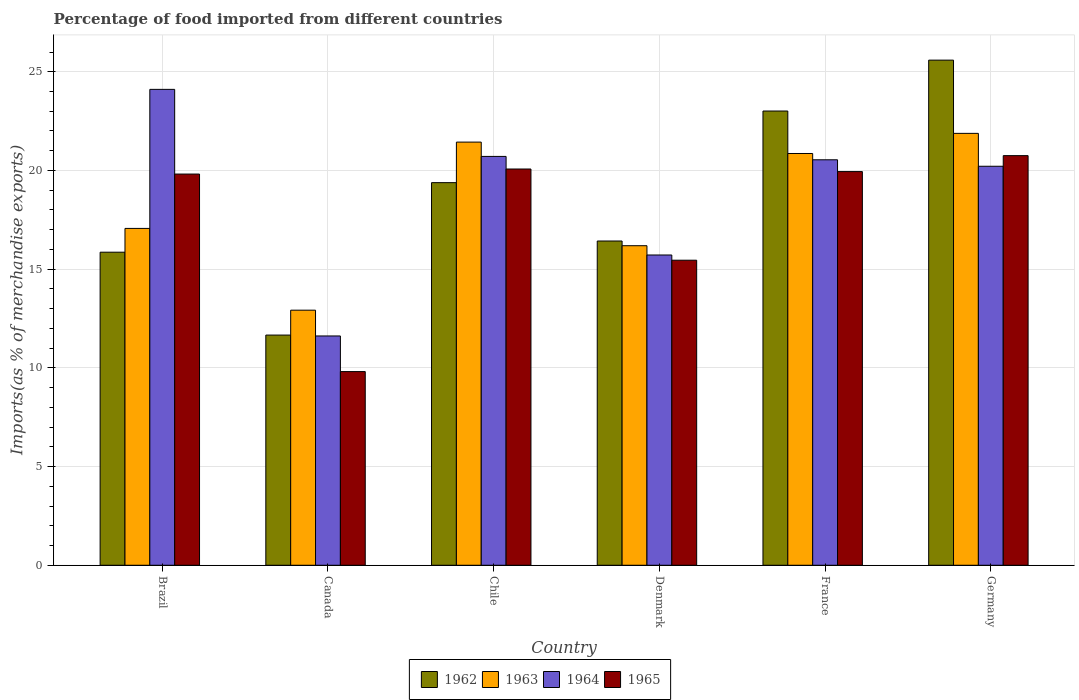How many groups of bars are there?
Your response must be concise. 6. Are the number of bars on each tick of the X-axis equal?
Give a very brief answer. Yes. How many bars are there on the 2nd tick from the left?
Keep it short and to the point. 4. How many bars are there on the 5th tick from the right?
Keep it short and to the point. 4. In how many cases, is the number of bars for a given country not equal to the number of legend labels?
Give a very brief answer. 0. What is the percentage of imports to different countries in 1965 in Chile?
Provide a succinct answer. 20.07. Across all countries, what is the maximum percentage of imports to different countries in 1963?
Your answer should be very brief. 21.88. Across all countries, what is the minimum percentage of imports to different countries in 1962?
Your answer should be very brief. 11.66. What is the total percentage of imports to different countries in 1962 in the graph?
Your answer should be very brief. 111.93. What is the difference between the percentage of imports to different countries in 1964 in Chile and that in Denmark?
Give a very brief answer. 4.99. What is the difference between the percentage of imports to different countries in 1963 in Denmark and the percentage of imports to different countries in 1965 in Germany?
Provide a succinct answer. -4.56. What is the average percentage of imports to different countries in 1962 per country?
Ensure brevity in your answer.  18.66. What is the difference between the percentage of imports to different countries of/in 1962 and percentage of imports to different countries of/in 1964 in Brazil?
Offer a terse response. -8.25. In how many countries, is the percentage of imports to different countries in 1965 greater than 25 %?
Your answer should be compact. 0. What is the ratio of the percentage of imports to different countries in 1963 in France to that in Germany?
Give a very brief answer. 0.95. Is the percentage of imports to different countries in 1963 in Brazil less than that in Chile?
Keep it short and to the point. Yes. What is the difference between the highest and the second highest percentage of imports to different countries in 1965?
Offer a very short reply. -0.81. What is the difference between the highest and the lowest percentage of imports to different countries in 1962?
Provide a succinct answer. 13.93. In how many countries, is the percentage of imports to different countries in 1965 greater than the average percentage of imports to different countries in 1965 taken over all countries?
Provide a short and direct response. 4. What does the 2nd bar from the right in Brazil represents?
Offer a very short reply. 1964. Are all the bars in the graph horizontal?
Offer a very short reply. No. How many countries are there in the graph?
Ensure brevity in your answer.  6. Are the values on the major ticks of Y-axis written in scientific E-notation?
Provide a short and direct response. No. Does the graph contain any zero values?
Offer a very short reply. No. Does the graph contain grids?
Your response must be concise. Yes. Where does the legend appear in the graph?
Your answer should be very brief. Bottom center. What is the title of the graph?
Make the answer very short. Percentage of food imported from different countries. Does "1979" appear as one of the legend labels in the graph?
Your answer should be very brief. No. What is the label or title of the X-axis?
Provide a short and direct response. Country. What is the label or title of the Y-axis?
Provide a succinct answer. Imports(as % of merchandise exports). What is the Imports(as % of merchandise exports) in 1962 in Brazil?
Provide a short and direct response. 15.86. What is the Imports(as % of merchandise exports) in 1963 in Brazil?
Make the answer very short. 17.06. What is the Imports(as % of merchandise exports) in 1964 in Brazil?
Give a very brief answer. 24.11. What is the Imports(as % of merchandise exports) in 1965 in Brazil?
Your answer should be very brief. 19.82. What is the Imports(as % of merchandise exports) in 1962 in Canada?
Give a very brief answer. 11.66. What is the Imports(as % of merchandise exports) in 1963 in Canada?
Make the answer very short. 12.92. What is the Imports(as % of merchandise exports) of 1964 in Canada?
Provide a succinct answer. 11.62. What is the Imports(as % of merchandise exports) in 1965 in Canada?
Your answer should be compact. 9.81. What is the Imports(as % of merchandise exports) of 1962 in Chile?
Make the answer very short. 19.38. What is the Imports(as % of merchandise exports) in 1963 in Chile?
Your response must be concise. 21.44. What is the Imports(as % of merchandise exports) of 1964 in Chile?
Your answer should be very brief. 20.71. What is the Imports(as % of merchandise exports) in 1965 in Chile?
Ensure brevity in your answer.  20.07. What is the Imports(as % of merchandise exports) in 1962 in Denmark?
Offer a terse response. 16.43. What is the Imports(as % of merchandise exports) in 1963 in Denmark?
Your answer should be compact. 16.19. What is the Imports(as % of merchandise exports) of 1964 in Denmark?
Your response must be concise. 15.72. What is the Imports(as % of merchandise exports) of 1965 in Denmark?
Your response must be concise. 15.45. What is the Imports(as % of merchandise exports) in 1962 in France?
Keep it short and to the point. 23.01. What is the Imports(as % of merchandise exports) in 1963 in France?
Your answer should be very brief. 20.86. What is the Imports(as % of merchandise exports) in 1964 in France?
Your response must be concise. 20.54. What is the Imports(as % of merchandise exports) in 1965 in France?
Your response must be concise. 19.94. What is the Imports(as % of merchandise exports) in 1962 in Germany?
Offer a very short reply. 25.59. What is the Imports(as % of merchandise exports) of 1963 in Germany?
Offer a very short reply. 21.88. What is the Imports(as % of merchandise exports) of 1964 in Germany?
Provide a succinct answer. 20.21. What is the Imports(as % of merchandise exports) in 1965 in Germany?
Ensure brevity in your answer.  20.75. Across all countries, what is the maximum Imports(as % of merchandise exports) in 1962?
Ensure brevity in your answer.  25.59. Across all countries, what is the maximum Imports(as % of merchandise exports) in 1963?
Provide a succinct answer. 21.88. Across all countries, what is the maximum Imports(as % of merchandise exports) of 1964?
Provide a succinct answer. 24.11. Across all countries, what is the maximum Imports(as % of merchandise exports) in 1965?
Provide a short and direct response. 20.75. Across all countries, what is the minimum Imports(as % of merchandise exports) in 1962?
Your answer should be very brief. 11.66. Across all countries, what is the minimum Imports(as % of merchandise exports) in 1963?
Offer a very short reply. 12.92. Across all countries, what is the minimum Imports(as % of merchandise exports) in 1964?
Your response must be concise. 11.62. Across all countries, what is the minimum Imports(as % of merchandise exports) in 1965?
Ensure brevity in your answer.  9.81. What is the total Imports(as % of merchandise exports) in 1962 in the graph?
Give a very brief answer. 111.93. What is the total Imports(as % of merchandise exports) in 1963 in the graph?
Offer a terse response. 110.35. What is the total Imports(as % of merchandise exports) of 1964 in the graph?
Your answer should be compact. 112.91. What is the total Imports(as % of merchandise exports) of 1965 in the graph?
Offer a very short reply. 105.85. What is the difference between the Imports(as % of merchandise exports) of 1962 in Brazil and that in Canada?
Give a very brief answer. 4.2. What is the difference between the Imports(as % of merchandise exports) of 1963 in Brazil and that in Canada?
Your response must be concise. 4.14. What is the difference between the Imports(as % of merchandise exports) of 1964 in Brazil and that in Canada?
Offer a terse response. 12.49. What is the difference between the Imports(as % of merchandise exports) in 1965 in Brazil and that in Canada?
Ensure brevity in your answer.  10.01. What is the difference between the Imports(as % of merchandise exports) in 1962 in Brazil and that in Chile?
Offer a very short reply. -3.52. What is the difference between the Imports(as % of merchandise exports) in 1963 in Brazil and that in Chile?
Make the answer very short. -4.37. What is the difference between the Imports(as % of merchandise exports) of 1964 in Brazil and that in Chile?
Keep it short and to the point. 3.4. What is the difference between the Imports(as % of merchandise exports) of 1965 in Brazil and that in Chile?
Keep it short and to the point. -0.26. What is the difference between the Imports(as % of merchandise exports) of 1962 in Brazil and that in Denmark?
Give a very brief answer. -0.57. What is the difference between the Imports(as % of merchandise exports) of 1963 in Brazil and that in Denmark?
Ensure brevity in your answer.  0.88. What is the difference between the Imports(as % of merchandise exports) in 1964 in Brazil and that in Denmark?
Offer a very short reply. 8.39. What is the difference between the Imports(as % of merchandise exports) in 1965 in Brazil and that in Denmark?
Offer a terse response. 4.36. What is the difference between the Imports(as % of merchandise exports) in 1962 in Brazil and that in France?
Your answer should be very brief. -7.15. What is the difference between the Imports(as % of merchandise exports) in 1963 in Brazil and that in France?
Provide a short and direct response. -3.8. What is the difference between the Imports(as % of merchandise exports) of 1964 in Brazil and that in France?
Ensure brevity in your answer.  3.57. What is the difference between the Imports(as % of merchandise exports) in 1965 in Brazil and that in France?
Your answer should be compact. -0.13. What is the difference between the Imports(as % of merchandise exports) in 1962 in Brazil and that in Germany?
Provide a succinct answer. -9.73. What is the difference between the Imports(as % of merchandise exports) in 1963 in Brazil and that in Germany?
Your response must be concise. -4.81. What is the difference between the Imports(as % of merchandise exports) in 1964 in Brazil and that in Germany?
Provide a short and direct response. 3.9. What is the difference between the Imports(as % of merchandise exports) of 1965 in Brazil and that in Germany?
Your answer should be very brief. -0.93. What is the difference between the Imports(as % of merchandise exports) of 1962 in Canada and that in Chile?
Give a very brief answer. -7.72. What is the difference between the Imports(as % of merchandise exports) in 1963 in Canada and that in Chile?
Give a very brief answer. -8.51. What is the difference between the Imports(as % of merchandise exports) of 1964 in Canada and that in Chile?
Provide a short and direct response. -9.1. What is the difference between the Imports(as % of merchandise exports) in 1965 in Canada and that in Chile?
Offer a very short reply. -10.26. What is the difference between the Imports(as % of merchandise exports) of 1962 in Canada and that in Denmark?
Keep it short and to the point. -4.77. What is the difference between the Imports(as % of merchandise exports) in 1963 in Canada and that in Denmark?
Provide a short and direct response. -3.27. What is the difference between the Imports(as % of merchandise exports) in 1964 in Canada and that in Denmark?
Make the answer very short. -4.1. What is the difference between the Imports(as % of merchandise exports) in 1965 in Canada and that in Denmark?
Your answer should be very brief. -5.64. What is the difference between the Imports(as % of merchandise exports) of 1962 in Canada and that in France?
Keep it short and to the point. -11.35. What is the difference between the Imports(as % of merchandise exports) in 1963 in Canada and that in France?
Your answer should be compact. -7.94. What is the difference between the Imports(as % of merchandise exports) of 1964 in Canada and that in France?
Keep it short and to the point. -8.92. What is the difference between the Imports(as % of merchandise exports) of 1965 in Canada and that in France?
Provide a short and direct response. -10.13. What is the difference between the Imports(as % of merchandise exports) of 1962 in Canada and that in Germany?
Your answer should be compact. -13.93. What is the difference between the Imports(as % of merchandise exports) in 1963 in Canada and that in Germany?
Your answer should be very brief. -8.96. What is the difference between the Imports(as % of merchandise exports) in 1964 in Canada and that in Germany?
Ensure brevity in your answer.  -8.6. What is the difference between the Imports(as % of merchandise exports) in 1965 in Canada and that in Germany?
Provide a short and direct response. -10.94. What is the difference between the Imports(as % of merchandise exports) of 1962 in Chile and that in Denmark?
Make the answer very short. 2.96. What is the difference between the Imports(as % of merchandise exports) of 1963 in Chile and that in Denmark?
Give a very brief answer. 5.25. What is the difference between the Imports(as % of merchandise exports) of 1964 in Chile and that in Denmark?
Your answer should be very brief. 4.99. What is the difference between the Imports(as % of merchandise exports) of 1965 in Chile and that in Denmark?
Make the answer very short. 4.62. What is the difference between the Imports(as % of merchandise exports) of 1962 in Chile and that in France?
Your answer should be compact. -3.63. What is the difference between the Imports(as % of merchandise exports) in 1963 in Chile and that in France?
Offer a terse response. 0.58. What is the difference between the Imports(as % of merchandise exports) in 1964 in Chile and that in France?
Make the answer very short. 0.17. What is the difference between the Imports(as % of merchandise exports) in 1965 in Chile and that in France?
Your answer should be compact. 0.13. What is the difference between the Imports(as % of merchandise exports) in 1962 in Chile and that in Germany?
Your answer should be compact. -6.21. What is the difference between the Imports(as % of merchandise exports) in 1963 in Chile and that in Germany?
Provide a short and direct response. -0.44. What is the difference between the Imports(as % of merchandise exports) in 1964 in Chile and that in Germany?
Provide a short and direct response. 0.5. What is the difference between the Imports(as % of merchandise exports) in 1965 in Chile and that in Germany?
Offer a very short reply. -0.68. What is the difference between the Imports(as % of merchandise exports) of 1962 in Denmark and that in France?
Offer a terse response. -6.59. What is the difference between the Imports(as % of merchandise exports) in 1963 in Denmark and that in France?
Your answer should be compact. -4.67. What is the difference between the Imports(as % of merchandise exports) in 1964 in Denmark and that in France?
Your answer should be very brief. -4.82. What is the difference between the Imports(as % of merchandise exports) of 1965 in Denmark and that in France?
Provide a succinct answer. -4.49. What is the difference between the Imports(as % of merchandise exports) of 1962 in Denmark and that in Germany?
Offer a very short reply. -9.16. What is the difference between the Imports(as % of merchandise exports) in 1963 in Denmark and that in Germany?
Make the answer very short. -5.69. What is the difference between the Imports(as % of merchandise exports) of 1964 in Denmark and that in Germany?
Make the answer very short. -4.49. What is the difference between the Imports(as % of merchandise exports) in 1965 in Denmark and that in Germany?
Provide a succinct answer. -5.3. What is the difference between the Imports(as % of merchandise exports) in 1962 in France and that in Germany?
Provide a short and direct response. -2.58. What is the difference between the Imports(as % of merchandise exports) in 1963 in France and that in Germany?
Your response must be concise. -1.02. What is the difference between the Imports(as % of merchandise exports) in 1964 in France and that in Germany?
Offer a very short reply. 0.33. What is the difference between the Imports(as % of merchandise exports) of 1965 in France and that in Germany?
Your response must be concise. -0.81. What is the difference between the Imports(as % of merchandise exports) in 1962 in Brazil and the Imports(as % of merchandise exports) in 1963 in Canada?
Provide a succinct answer. 2.94. What is the difference between the Imports(as % of merchandise exports) in 1962 in Brazil and the Imports(as % of merchandise exports) in 1964 in Canada?
Make the answer very short. 4.24. What is the difference between the Imports(as % of merchandise exports) in 1962 in Brazil and the Imports(as % of merchandise exports) in 1965 in Canada?
Offer a terse response. 6.05. What is the difference between the Imports(as % of merchandise exports) in 1963 in Brazil and the Imports(as % of merchandise exports) in 1964 in Canada?
Make the answer very short. 5.45. What is the difference between the Imports(as % of merchandise exports) of 1963 in Brazil and the Imports(as % of merchandise exports) of 1965 in Canada?
Offer a very short reply. 7.25. What is the difference between the Imports(as % of merchandise exports) of 1964 in Brazil and the Imports(as % of merchandise exports) of 1965 in Canada?
Ensure brevity in your answer.  14.3. What is the difference between the Imports(as % of merchandise exports) of 1962 in Brazil and the Imports(as % of merchandise exports) of 1963 in Chile?
Your answer should be very brief. -5.58. What is the difference between the Imports(as % of merchandise exports) in 1962 in Brazil and the Imports(as % of merchandise exports) in 1964 in Chile?
Provide a short and direct response. -4.85. What is the difference between the Imports(as % of merchandise exports) in 1962 in Brazil and the Imports(as % of merchandise exports) in 1965 in Chile?
Your answer should be very brief. -4.21. What is the difference between the Imports(as % of merchandise exports) of 1963 in Brazil and the Imports(as % of merchandise exports) of 1964 in Chile?
Provide a succinct answer. -3.65. What is the difference between the Imports(as % of merchandise exports) in 1963 in Brazil and the Imports(as % of merchandise exports) in 1965 in Chile?
Give a very brief answer. -3.01. What is the difference between the Imports(as % of merchandise exports) in 1964 in Brazil and the Imports(as % of merchandise exports) in 1965 in Chile?
Offer a terse response. 4.03. What is the difference between the Imports(as % of merchandise exports) of 1962 in Brazil and the Imports(as % of merchandise exports) of 1963 in Denmark?
Give a very brief answer. -0.33. What is the difference between the Imports(as % of merchandise exports) in 1962 in Brazil and the Imports(as % of merchandise exports) in 1964 in Denmark?
Keep it short and to the point. 0.14. What is the difference between the Imports(as % of merchandise exports) of 1962 in Brazil and the Imports(as % of merchandise exports) of 1965 in Denmark?
Your answer should be very brief. 0.41. What is the difference between the Imports(as % of merchandise exports) of 1963 in Brazil and the Imports(as % of merchandise exports) of 1964 in Denmark?
Offer a terse response. 1.35. What is the difference between the Imports(as % of merchandise exports) in 1963 in Brazil and the Imports(as % of merchandise exports) in 1965 in Denmark?
Offer a very short reply. 1.61. What is the difference between the Imports(as % of merchandise exports) in 1964 in Brazil and the Imports(as % of merchandise exports) in 1965 in Denmark?
Offer a very short reply. 8.65. What is the difference between the Imports(as % of merchandise exports) in 1962 in Brazil and the Imports(as % of merchandise exports) in 1963 in France?
Give a very brief answer. -5. What is the difference between the Imports(as % of merchandise exports) in 1962 in Brazil and the Imports(as % of merchandise exports) in 1964 in France?
Make the answer very short. -4.68. What is the difference between the Imports(as % of merchandise exports) in 1962 in Brazil and the Imports(as % of merchandise exports) in 1965 in France?
Make the answer very short. -4.08. What is the difference between the Imports(as % of merchandise exports) of 1963 in Brazil and the Imports(as % of merchandise exports) of 1964 in France?
Keep it short and to the point. -3.48. What is the difference between the Imports(as % of merchandise exports) of 1963 in Brazil and the Imports(as % of merchandise exports) of 1965 in France?
Offer a terse response. -2.88. What is the difference between the Imports(as % of merchandise exports) in 1964 in Brazil and the Imports(as % of merchandise exports) in 1965 in France?
Offer a terse response. 4.16. What is the difference between the Imports(as % of merchandise exports) of 1962 in Brazil and the Imports(as % of merchandise exports) of 1963 in Germany?
Ensure brevity in your answer.  -6.02. What is the difference between the Imports(as % of merchandise exports) of 1962 in Brazil and the Imports(as % of merchandise exports) of 1964 in Germany?
Keep it short and to the point. -4.35. What is the difference between the Imports(as % of merchandise exports) of 1962 in Brazil and the Imports(as % of merchandise exports) of 1965 in Germany?
Provide a short and direct response. -4.89. What is the difference between the Imports(as % of merchandise exports) of 1963 in Brazil and the Imports(as % of merchandise exports) of 1964 in Germany?
Ensure brevity in your answer.  -3.15. What is the difference between the Imports(as % of merchandise exports) of 1963 in Brazil and the Imports(as % of merchandise exports) of 1965 in Germany?
Your answer should be very brief. -3.69. What is the difference between the Imports(as % of merchandise exports) in 1964 in Brazil and the Imports(as % of merchandise exports) in 1965 in Germany?
Make the answer very short. 3.36. What is the difference between the Imports(as % of merchandise exports) of 1962 in Canada and the Imports(as % of merchandise exports) of 1963 in Chile?
Your response must be concise. -9.78. What is the difference between the Imports(as % of merchandise exports) of 1962 in Canada and the Imports(as % of merchandise exports) of 1964 in Chile?
Your response must be concise. -9.05. What is the difference between the Imports(as % of merchandise exports) of 1962 in Canada and the Imports(as % of merchandise exports) of 1965 in Chile?
Provide a succinct answer. -8.41. What is the difference between the Imports(as % of merchandise exports) of 1963 in Canada and the Imports(as % of merchandise exports) of 1964 in Chile?
Your answer should be compact. -7.79. What is the difference between the Imports(as % of merchandise exports) of 1963 in Canada and the Imports(as % of merchandise exports) of 1965 in Chile?
Give a very brief answer. -7.15. What is the difference between the Imports(as % of merchandise exports) of 1964 in Canada and the Imports(as % of merchandise exports) of 1965 in Chile?
Provide a succinct answer. -8.46. What is the difference between the Imports(as % of merchandise exports) in 1962 in Canada and the Imports(as % of merchandise exports) in 1963 in Denmark?
Ensure brevity in your answer.  -4.53. What is the difference between the Imports(as % of merchandise exports) of 1962 in Canada and the Imports(as % of merchandise exports) of 1964 in Denmark?
Provide a succinct answer. -4.06. What is the difference between the Imports(as % of merchandise exports) of 1962 in Canada and the Imports(as % of merchandise exports) of 1965 in Denmark?
Ensure brevity in your answer.  -3.79. What is the difference between the Imports(as % of merchandise exports) of 1963 in Canada and the Imports(as % of merchandise exports) of 1964 in Denmark?
Your answer should be compact. -2.8. What is the difference between the Imports(as % of merchandise exports) of 1963 in Canada and the Imports(as % of merchandise exports) of 1965 in Denmark?
Ensure brevity in your answer.  -2.53. What is the difference between the Imports(as % of merchandise exports) of 1964 in Canada and the Imports(as % of merchandise exports) of 1965 in Denmark?
Offer a terse response. -3.84. What is the difference between the Imports(as % of merchandise exports) in 1962 in Canada and the Imports(as % of merchandise exports) in 1963 in France?
Keep it short and to the point. -9.2. What is the difference between the Imports(as % of merchandise exports) of 1962 in Canada and the Imports(as % of merchandise exports) of 1964 in France?
Offer a terse response. -8.88. What is the difference between the Imports(as % of merchandise exports) of 1962 in Canada and the Imports(as % of merchandise exports) of 1965 in France?
Offer a terse response. -8.28. What is the difference between the Imports(as % of merchandise exports) in 1963 in Canada and the Imports(as % of merchandise exports) in 1964 in France?
Your response must be concise. -7.62. What is the difference between the Imports(as % of merchandise exports) of 1963 in Canada and the Imports(as % of merchandise exports) of 1965 in France?
Your answer should be very brief. -7.02. What is the difference between the Imports(as % of merchandise exports) of 1964 in Canada and the Imports(as % of merchandise exports) of 1965 in France?
Your response must be concise. -8.33. What is the difference between the Imports(as % of merchandise exports) of 1962 in Canada and the Imports(as % of merchandise exports) of 1963 in Germany?
Your answer should be compact. -10.22. What is the difference between the Imports(as % of merchandise exports) in 1962 in Canada and the Imports(as % of merchandise exports) in 1964 in Germany?
Provide a succinct answer. -8.55. What is the difference between the Imports(as % of merchandise exports) in 1962 in Canada and the Imports(as % of merchandise exports) in 1965 in Germany?
Your response must be concise. -9.09. What is the difference between the Imports(as % of merchandise exports) in 1963 in Canada and the Imports(as % of merchandise exports) in 1964 in Germany?
Your answer should be very brief. -7.29. What is the difference between the Imports(as % of merchandise exports) of 1963 in Canada and the Imports(as % of merchandise exports) of 1965 in Germany?
Ensure brevity in your answer.  -7.83. What is the difference between the Imports(as % of merchandise exports) in 1964 in Canada and the Imports(as % of merchandise exports) in 1965 in Germany?
Make the answer very short. -9.13. What is the difference between the Imports(as % of merchandise exports) in 1962 in Chile and the Imports(as % of merchandise exports) in 1963 in Denmark?
Your response must be concise. 3.19. What is the difference between the Imports(as % of merchandise exports) in 1962 in Chile and the Imports(as % of merchandise exports) in 1964 in Denmark?
Your response must be concise. 3.66. What is the difference between the Imports(as % of merchandise exports) of 1962 in Chile and the Imports(as % of merchandise exports) of 1965 in Denmark?
Ensure brevity in your answer.  3.93. What is the difference between the Imports(as % of merchandise exports) of 1963 in Chile and the Imports(as % of merchandise exports) of 1964 in Denmark?
Your answer should be compact. 5.72. What is the difference between the Imports(as % of merchandise exports) of 1963 in Chile and the Imports(as % of merchandise exports) of 1965 in Denmark?
Your answer should be very brief. 5.98. What is the difference between the Imports(as % of merchandise exports) of 1964 in Chile and the Imports(as % of merchandise exports) of 1965 in Denmark?
Provide a short and direct response. 5.26. What is the difference between the Imports(as % of merchandise exports) of 1962 in Chile and the Imports(as % of merchandise exports) of 1963 in France?
Offer a terse response. -1.48. What is the difference between the Imports(as % of merchandise exports) in 1962 in Chile and the Imports(as % of merchandise exports) in 1964 in France?
Offer a very short reply. -1.16. What is the difference between the Imports(as % of merchandise exports) in 1962 in Chile and the Imports(as % of merchandise exports) in 1965 in France?
Make the answer very short. -0.56. What is the difference between the Imports(as % of merchandise exports) of 1963 in Chile and the Imports(as % of merchandise exports) of 1964 in France?
Your answer should be compact. 0.9. What is the difference between the Imports(as % of merchandise exports) in 1963 in Chile and the Imports(as % of merchandise exports) in 1965 in France?
Provide a short and direct response. 1.49. What is the difference between the Imports(as % of merchandise exports) of 1964 in Chile and the Imports(as % of merchandise exports) of 1965 in France?
Ensure brevity in your answer.  0.77. What is the difference between the Imports(as % of merchandise exports) in 1962 in Chile and the Imports(as % of merchandise exports) in 1963 in Germany?
Keep it short and to the point. -2.5. What is the difference between the Imports(as % of merchandise exports) of 1962 in Chile and the Imports(as % of merchandise exports) of 1964 in Germany?
Provide a short and direct response. -0.83. What is the difference between the Imports(as % of merchandise exports) in 1962 in Chile and the Imports(as % of merchandise exports) in 1965 in Germany?
Your response must be concise. -1.37. What is the difference between the Imports(as % of merchandise exports) in 1963 in Chile and the Imports(as % of merchandise exports) in 1964 in Germany?
Offer a terse response. 1.22. What is the difference between the Imports(as % of merchandise exports) of 1963 in Chile and the Imports(as % of merchandise exports) of 1965 in Germany?
Give a very brief answer. 0.69. What is the difference between the Imports(as % of merchandise exports) in 1964 in Chile and the Imports(as % of merchandise exports) in 1965 in Germany?
Provide a succinct answer. -0.04. What is the difference between the Imports(as % of merchandise exports) of 1962 in Denmark and the Imports(as % of merchandise exports) of 1963 in France?
Give a very brief answer. -4.43. What is the difference between the Imports(as % of merchandise exports) in 1962 in Denmark and the Imports(as % of merchandise exports) in 1964 in France?
Provide a short and direct response. -4.11. What is the difference between the Imports(as % of merchandise exports) in 1962 in Denmark and the Imports(as % of merchandise exports) in 1965 in France?
Ensure brevity in your answer.  -3.52. What is the difference between the Imports(as % of merchandise exports) of 1963 in Denmark and the Imports(as % of merchandise exports) of 1964 in France?
Your response must be concise. -4.35. What is the difference between the Imports(as % of merchandise exports) of 1963 in Denmark and the Imports(as % of merchandise exports) of 1965 in France?
Provide a succinct answer. -3.76. What is the difference between the Imports(as % of merchandise exports) of 1964 in Denmark and the Imports(as % of merchandise exports) of 1965 in France?
Give a very brief answer. -4.23. What is the difference between the Imports(as % of merchandise exports) of 1962 in Denmark and the Imports(as % of merchandise exports) of 1963 in Germany?
Ensure brevity in your answer.  -5.45. What is the difference between the Imports(as % of merchandise exports) in 1962 in Denmark and the Imports(as % of merchandise exports) in 1964 in Germany?
Ensure brevity in your answer.  -3.79. What is the difference between the Imports(as % of merchandise exports) in 1962 in Denmark and the Imports(as % of merchandise exports) in 1965 in Germany?
Your response must be concise. -4.32. What is the difference between the Imports(as % of merchandise exports) in 1963 in Denmark and the Imports(as % of merchandise exports) in 1964 in Germany?
Provide a succinct answer. -4.02. What is the difference between the Imports(as % of merchandise exports) of 1963 in Denmark and the Imports(as % of merchandise exports) of 1965 in Germany?
Make the answer very short. -4.56. What is the difference between the Imports(as % of merchandise exports) of 1964 in Denmark and the Imports(as % of merchandise exports) of 1965 in Germany?
Give a very brief answer. -5.03. What is the difference between the Imports(as % of merchandise exports) of 1962 in France and the Imports(as % of merchandise exports) of 1963 in Germany?
Offer a terse response. 1.13. What is the difference between the Imports(as % of merchandise exports) in 1962 in France and the Imports(as % of merchandise exports) in 1964 in Germany?
Your answer should be compact. 2.8. What is the difference between the Imports(as % of merchandise exports) of 1962 in France and the Imports(as % of merchandise exports) of 1965 in Germany?
Give a very brief answer. 2.26. What is the difference between the Imports(as % of merchandise exports) in 1963 in France and the Imports(as % of merchandise exports) in 1964 in Germany?
Your answer should be compact. 0.65. What is the difference between the Imports(as % of merchandise exports) of 1963 in France and the Imports(as % of merchandise exports) of 1965 in Germany?
Your answer should be compact. 0.11. What is the difference between the Imports(as % of merchandise exports) of 1964 in France and the Imports(as % of merchandise exports) of 1965 in Germany?
Offer a very short reply. -0.21. What is the average Imports(as % of merchandise exports) in 1962 per country?
Provide a short and direct response. 18.66. What is the average Imports(as % of merchandise exports) in 1963 per country?
Provide a succinct answer. 18.39. What is the average Imports(as % of merchandise exports) in 1964 per country?
Your answer should be very brief. 18.82. What is the average Imports(as % of merchandise exports) of 1965 per country?
Ensure brevity in your answer.  17.64. What is the difference between the Imports(as % of merchandise exports) of 1962 and Imports(as % of merchandise exports) of 1963 in Brazil?
Keep it short and to the point. -1.2. What is the difference between the Imports(as % of merchandise exports) in 1962 and Imports(as % of merchandise exports) in 1964 in Brazil?
Keep it short and to the point. -8.25. What is the difference between the Imports(as % of merchandise exports) in 1962 and Imports(as % of merchandise exports) in 1965 in Brazil?
Keep it short and to the point. -3.96. What is the difference between the Imports(as % of merchandise exports) in 1963 and Imports(as % of merchandise exports) in 1964 in Brazil?
Your answer should be very brief. -7.04. What is the difference between the Imports(as % of merchandise exports) in 1963 and Imports(as % of merchandise exports) in 1965 in Brazil?
Provide a succinct answer. -2.75. What is the difference between the Imports(as % of merchandise exports) of 1964 and Imports(as % of merchandise exports) of 1965 in Brazil?
Offer a very short reply. 4.29. What is the difference between the Imports(as % of merchandise exports) of 1962 and Imports(as % of merchandise exports) of 1963 in Canada?
Your response must be concise. -1.26. What is the difference between the Imports(as % of merchandise exports) in 1962 and Imports(as % of merchandise exports) in 1964 in Canada?
Ensure brevity in your answer.  0.05. What is the difference between the Imports(as % of merchandise exports) of 1962 and Imports(as % of merchandise exports) of 1965 in Canada?
Your answer should be very brief. 1.85. What is the difference between the Imports(as % of merchandise exports) of 1963 and Imports(as % of merchandise exports) of 1964 in Canada?
Keep it short and to the point. 1.31. What is the difference between the Imports(as % of merchandise exports) of 1963 and Imports(as % of merchandise exports) of 1965 in Canada?
Your answer should be very brief. 3.11. What is the difference between the Imports(as % of merchandise exports) of 1964 and Imports(as % of merchandise exports) of 1965 in Canada?
Your answer should be compact. 1.8. What is the difference between the Imports(as % of merchandise exports) in 1962 and Imports(as % of merchandise exports) in 1963 in Chile?
Offer a very short reply. -2.05. What is the difference between the Imports(as % of merchandise exports) in 1962 and Imports(as % of merchandise exports) in 1964 in Chile?
Your answer should be compact. -1.33. What is the difference between the Imports(as % of merchandise exports) of 1962 and Imports(as % of merchandise exports) of 1965 in Chile?
Give a very brief answer. -0.69. What is the difference between the Imports(as % of merchandise exports) of 1963 and Imports(as % of merchandise exports) of 1964 in Chile?
Offer a terse response. 0.72. What is the difference between the Imports(as % of merchandise exports) of 1963 and Imports(as % of merchandise exports) of 1965 in Chile?
Offer a very short reply. 1.36. What is the difference between the Imports(as % of merchandise exports) in 1964 and Imports(as % of merchandise exports) in 1965 in Chile?
Your answer should be compact. 0.64. What is the difference between the Imports(as % of merchandise exports) of 1962 and Imports(as % of merchandise exports) of 1963 in Denmark?
Give a very brief answer. 0.24. What is the difference between the Imports(as % of merchandise exports) in 1962 and Imports(as % of merchandise exports) in 1964 in Denmark?
Your answer should be compact. 0.71. What is the difference between the Imports(as % of merchandise exports) in 1962 and Imports(as % of merchandise exports) in 1965 in Denmark?
Offer a very short reply. 0.97. What is the difference between the Imports(as % of merchandise exports) in 1963 and Imports(as % of merchandise exports) in 1964 in Denmark?
Provide a short and direct response. 0.47. What is the difference between the Imports(as % of merchandise exports) of 1963 and Imports(as % of merchandise exports) of 1965 in Denmark?
Your response must be concise. 0.73. What is the difference between the Imports(as % of merchandise exports) in 1964 and Imports(as % of merchandise exports) in 1965 in Denmark?
Give a very brief answer. 0.26. What is the difference between the Imports(as % of merchandise exports) in 1962 and Imports(as % of merchandise exports) in 1963 in France?
Offer a very short reply. 2.15. What is the difference between the Imports(as % of merchandise exports) in 1962 and Imports(as % of merchandise exports) in 1964 in France?
Your response must be concise. 2.47. What is the difference between the Imports(as % of merchandise exports) in 1962 and Imports(as % of merchandise exports) in 1965 in France?
Offer a very short reply. 3.07. What is the difference between the Imports(as % of merchandise exports) of 1963 and Imports(as % of merchandise exports) of 1964 in France?
Your response must be concise. 0.32. What is the difference between the Imports(as % of merchandise exports) of 1963 and Imports(as % of merchandise exports) of 1965 in France?
Your answer should be compact. 0.92. What is the difference between the Imports(as % of merchandise exports) in 1964 and Imports(as % of merchandise exports) in 1965 in France?
Your answer should be compact. 0.6. What is the difference between the Imports(as % of merchandise exports) in 1962 and Imports(as % of merchandise exports) in 1963 in Germany?
Your response must be concise. 3.71. What is the difference between the Imports(as % of merchandise exports) of 1962 and Imports(as % of merchandise exports) of 1964 in Germany?
Provide a succinct answer. 5.38. What is the difference between the Imports(as % of merchandise exports) in 1962 and Imports(as % of merchandise exports) in 1965 in Germany?
Provide a succinct answer. 4.84. What is the difference between the Imports(as % of merchandise exports) of 1963 and Imports(as % of merchandise exports) of 1964 in Germany?
Make the answer very short. 1.67. What is the difference between the Imports(as % of merchandise exports) in 1963 and Imports(as % of merchandise exports) in 1965 in Germany?
Your answer should be very brief. 1.13. What is the difference between the Imports(as % of merchandise exports) of 1964 and Imports(as % of merchandise exports) of 1965 in Germany?
Your answer should be compact. -0.54. What is the ratio of the Imports(as % of merchandise exports) of 1962 in Brazil to that in Canada?
Offer a terse response. 1.36. What is the ratio of the Imports(as % of merchandise exports) in 1963 in Brazil to that in Canada?
Offer a terse response. 1.32. What is the ratio of the Imports(as % of merchandise exports) in 1964 in Brazil to that in Canada?
Keep it short and to the point. 2.08. What is the ratio of the Imports(as % of merchandise exports) of 1965 in Brazil to that in Canada?
Your answer should be compact. 2.02. What is the ratio of the Imports(as % of merchandise exports) of 1962 in Brazil to that in Chile?
Your response must be concise. 0.82. What is the ratio of the Imports(as % of merchandise exports) of 1963 in Brazil to that in Chile?
Make the answer very short. 0.8. What is the ratio of the Imports(as % of merchandise exports) of 1964 in Brazil to that in Chile?
Make the answer very short. 1.16. What is the ratio of the Imports(as % of merchandise exports) in 1965 in Brazil to that in Chile?
Provide a succinct answer. 0.99. What is the ratio of the Imports(as % of merchandise exports) in 1962 in Brazil to that in Denmark?
Your answer should be compact. 0.97. What is the ratio of the Imports(as % of merchandise exports) of 1963 in Brazil to that in Denmark?
Your answer should be compact. 1.05. What is the ratio of the Imports(as % of merchandise exports) in 1964 in Brazil to that in Denmark?
Give a very brief answer. 1.53. What is the ratio of the Imports(as % of merchandise exports) in 1965 in Brazil to that in Denmark?
Provide a short and direct response. 1.28. What is the ratio of the Imports(as % of merchandise exports) in 1962 in Brazil to that in France?
Keep it short and to the point. 0.69. What is the ratio of the Imports(as % of merchandise exports) of 1963 in Brazil to that in France?
Provide a succinct answer. 0.82. What is the ratio of the Imports(as % of merchandise exports) in 1964 in Brazil to that in France?
Offer a very short reply. 1.17. What is the ratio of the Imports(as % of merchandise exports) in 1965 in Brazil to that in France?
Provide a short and direct response. 0.99. What is the ratio of the Imports(as % of merchandise exports) of 1962 in Brazil to that in Germany?
Provide a short and direct response. 0.62. What is the ratio of the Imports(as % of merchandise exports) of 1963 in Brazil to that in Germany?
Your response must be concise. 0.78. What is the ratio of the Imports(as % of merchandise exports) in 1964 in Brazil to that in Germany?
Offer a very short reply. 1.19. What is the ratio of the Imports(as % of merchandise exports) of 1965 in Brazil to that in Germany?
Offer a very short reply. 0.95. What is the ratio of the Imports(as % of merchandise exports) of 1962 in Canada to that in Chile?
Offer a terse response. 0.6. What is the ratio of the Imports(as % of merchandise exports) of 1963 in Canada to that in Chile?
Make the answer very short. 0.6. What is the ratio of the Imports(as % of merchandise exports) in 1964 in Canada to that in Chile?
Your response must be concise. 0.56. What is the ratio of the Imports(as % of merchandise exports) of 1965 in Canada to that in Chile?
Your answer should be very brief. 0.49. What is the ratio of the Imports(as % of merchandise exports) in 1962 in Canada to that in Denmark?
Your answer should be very brief. 0.71. What is the ratio of the Imports(as % of merchandise exports) of 1963 in Canada to that in Denmark?
Your answer should be very brief. 0.8. What is the ratio of the Imports(as % of merchandise exports) of 1964 in Canada to that in Denmark?
Give a very brief answer. 0.74. What is the ratio of the Imports(as % of merchandise exports) in 1965 in Canada to that in Denmark?
Give a very brief answer. 0.63. What is the ratio of the Imports(as % of merchandise exports) of 1962 in Canada to that in France?
Your response must be concise. 0.51. What is the ratio of the Imports(as % of merchandise exports) of 1963 in Canada to that in France?
Ensure brevity in your answer.  0.62. What is the ratio of the Imports(as % of merchandise exports) of 1964 in Canada to that in France?
Your answer should be compact. 0.57. What is the ratio of the Imports(as % of merchandise exports) in 1965 in Canada to that in France?
Offer a terse response. 0.49. What is the ratio of the Imports(as % of merchandise exports) of 1962 in Canada to that in Germany?
Your answer should be very brief. 0.46. What is the ratio of the Imports(as % of merchandise exports) in 1963 in Canada to that in Germany?
Provide a short and direct response. 0.59. What is the ratio of the Imports(as % of merchandise exports) of 1964 in Canada to that in Germany?
Your response must be concise. 0.57. What is the ratio of the Imports(as % of merchandise exports) of 1965 in Canada to that in Germany?
Keep it short and to the point. 0.47. What is the ratio of the Imports(as % of merchandise exports) of 1962 in Chile to that in Denmark?
Provide a short and direct response. 1.18. What is the ratio of the Imports(as % of merchandise exports) in 1963 in Chile to that in Denmark?
Your answer should be very brief. 1.32. What is the ratio of the Imports(as % of merchandise exports) of 1964 in Chile to that in Denmark?
Offer a terse response. 1.32. What is the ratio of the Imports(as % of merchandise exports) in 1965 in Chile to that in Denmark?
Offer a terse response. 1.3. What is the ratio of the Imports(as % of merchandise exports) in 1962 in Chile to that in France?
Offer a very short reply. 0.84. What is the ratio of the Imports(as % of merchandise exports) in 1963 in Chile to that in France?
Make the answer very short. 1.03. What is the ratio of the Imports(as % of merchandise exports) in 1964 in Chile to that in France?
Your answer should be compact. 1.01. What is the ratio of the Imports(as % of merchandise exports) in 1962 in Chile to that in Germany?
Give a very brief answer. 0.76. What is the ratio of the Imports(as % of merchandise exports) in 1963 in Chile to that in Germany?
Ensure brevity in your answer.  0.98. What is the ratio of the Imports(as % of merchandise exports) of 1964 in Chile to that in Germany?
Provide a succinct answer. 1.02. What is the ratio of the Imports(as % of merchandise exports) of 1965 in Chile to that in Germany?
Your answer should be compact. 0.97. What is the ratio of the Imports(as % of merchandise exports) in 1962 in Denmark to that in France?
Your answer should be very brief. 0.71. What is the ratio of the Imports(as % of merchandise exports) in 1963 in Denmark to that in France?
Provide a succinct answer. 0.78. What is the ratio of the Imports(as % of merchandise exports) of 1964 in Denmark to that in France?
Provide a short and direct response. 0.77. What is the ratio of the Imports(as % of merchandise exports) in 1965 in Denmark to that in France?
Ensure brevity in your answer.  0.77. What is the ratio of the Imports(as % of merchandise exports) of 1962 in Denmark to that in Germany?
Make the answer very short. 0.64. What is the ratio of the Imports(as % of merchandise exports) in 1963 in Denmark to that in Germany?
Offer a terse response. 0.74. What is the ratio of the Imports(as % of merchandise exports) of 1964 in Denmark to that in Germany?
Offer a very short reply. 0.78. What is the ratio of the Imports(as % of merchandise exports) in 1965 in Denmark to that in Germany?
Keep it short and to the point. 0.74. What is the ratio of the Imports(as % of merchandise exports) in 1962 in France to that in Germany?
Make the answer very short. 0.9. What is the ratio of the Imports(as % of merchandise exports) in 1963 in France to that in Germany?
Make the answer very short. 0.95. What is the ratio of the Imports(as % of merchandise exports) of 1964 in France to that in Germany?
Your response must be concise. 1.02. What is the ratio of the Imports(as % of merchandise exports) of 1965 in France to that in Germany?
Provide a succinct answer. 0.96. What is the difference between the highest and the second highest Imports(as % of merchandise exports) of 1962?
Offer a very short reply. 2.58. What is the difference between the highest and the second highest Imports(as % of merchandise exports) of 1963?
Offer a very short reply. 0.44. What is the difference between the highest and the second highest Imports(as % of merchandise exports) in 1964?
Your answer should be very brief. 3.4. What is the difference between the highest and the second highest Imports(as % of merchandise exports) in 1965?
Your answer should be compact. 0.68. What is the difference between the highest and the lowest Imports(as % of merchandise exports) in 1962?
Offer a terse response. 13.93. What is the difference between the highest and the lowest Imports(as % of merchandise exports) of 1963?
Provide a short and direct response. 8.96. What is the difference between the highest and the lowest Imports(as % of merchandise exports) of 1964?
Provide a succinct answer. 12.49. What is the difference between the highest and the lowest Imports(as % of merchandise exports) in 1965?
Keep it short and to the point. 10.94. 